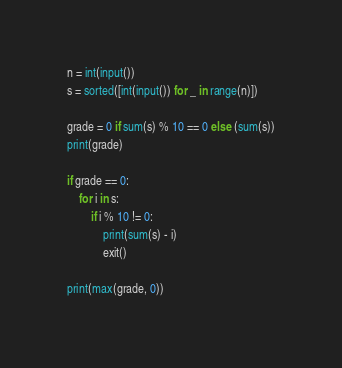<code> <loc_0><loc_0><loc_500><loc_500><_Python_>n = int(input())
s = sorted([int(input()) for _ in range(n)])

grade = 0 if sum(s) % 10 == 0 else (sum(s))
print(grade)

if grade == 0:
    for i in s:
        if i % 10 != 0:
            print(sum(s) - i)
            exit()

print(max(grade, 0))
</code> 